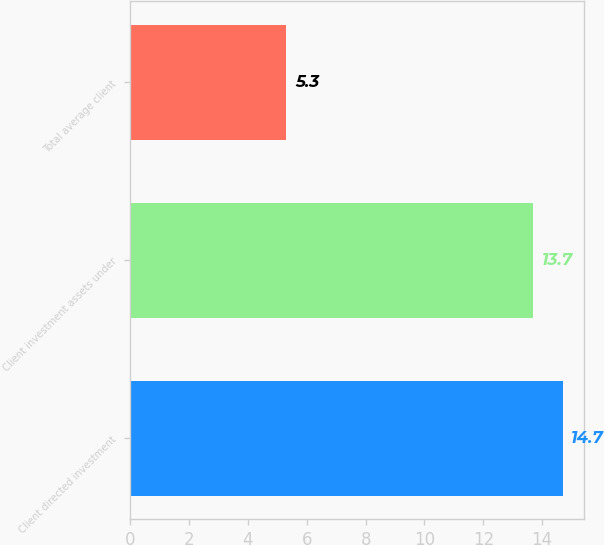Convert chart. <chart><loc_0><loc_0><loc_500><loc_500><bar_chart><fcel>Client directed investment<fcel>Client investment assets under<fcel>Total average client<nl><fcel>14.7<fcel>13.7<fcel>5.3<nl></chart> 